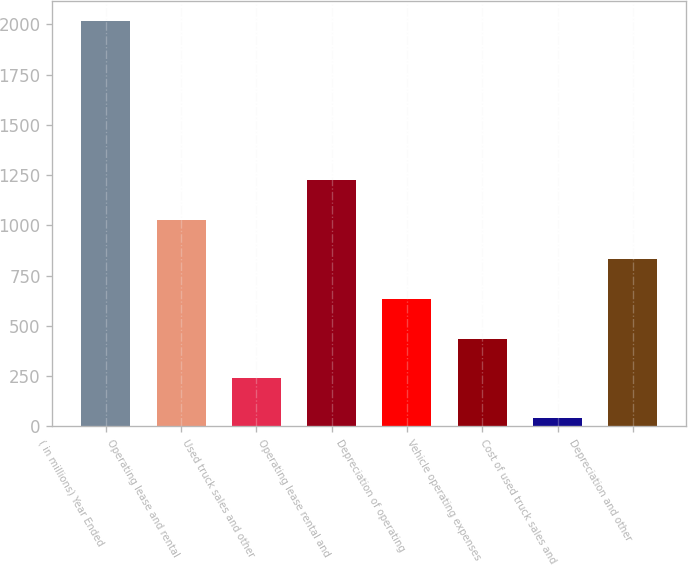<chart> <loc_0><loc_0><loc_500><loc_500><bar_chart><fcel>( in millions) Year Ended<fcel>Operating lease and rental<fcel>Used truck sales and other<fcel>Operating lease rental and<fcel>Depreciation of operating<fcel>Vehicle operating expenses<fcel>Cost of used truck sales and<fcel>Depreciation and other<nl><fcel>2017<fcel>1028.75<fcel>238.15<fcel>1226.4<fcel>633.45<fcel>435.8<fcel>40.5<fcel>831.1<nl></chart> 